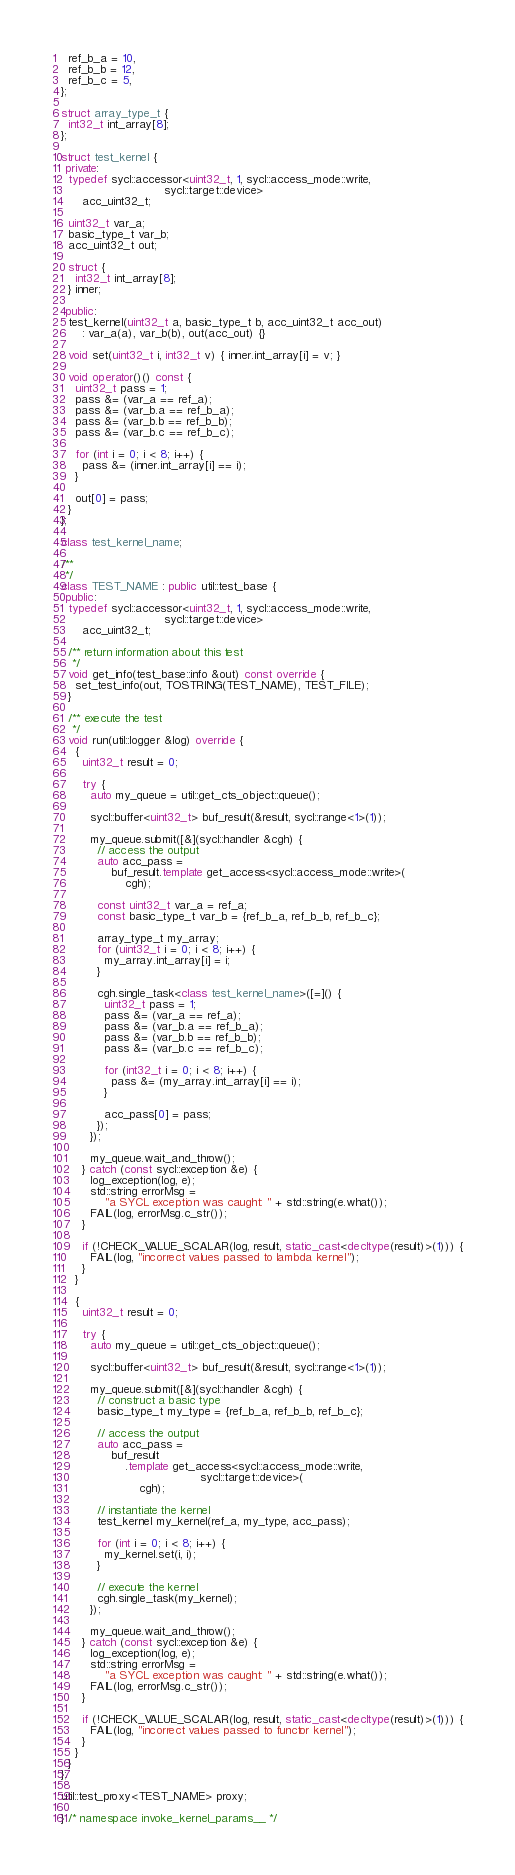Convert code to text. <code><loc_0><loc_0><loc_500><loc_500><_C++_>  ref_b_a = 10,
  ref_b_b = 12,
  ref_b_c = 5,
};

struct array_type_t {
  int32_t int_array[8];
};

struct test_kernel {
 private:
  typedef sycl::accessor<uint32_t, 1, sycl::access_mode::write,
                             sycl::target::device>
      acc_uint32_t;

  uint32_t var_a;
  basic_type_t var_b;
  acc_uint32_t out;

  struct {
    int32_t int_array[8];
  } inner;

 public:
  test_kernel(uint32_t a, basic_type_t b, acc_uint32_t acc_out)
      : var_a(a), var_b(b), out(acc_out) {}

  void set(uint32_t i, int32_t v) { inner.int_array[i] = v; }

  void operator()() const {
    uint32_t pass = 1;
    pass &= (var_a == ref_a);
    pass &= (var_b.a == ref_b_a);
    pass &= (var_b.b == ref_b_b);
    pass &= (var_b.c == ref_b_c);

    for (int i = 0; i < 8; i++) {
      pass &= (inner.int_array[i] == i);
    }

    out[0] = pass;
  }
};

class test_kernel_name;

/**
 */
class TEST_NAME : public util::test_base {
 public:
  typedef sycl::accessor<uint32_t, 1, sycl::access_mode::write,
                             sycl::target::device>
      acc_uint32_t;

  /** return information about this test
   */
  void get_info(test_base::info &out) const override {
    set_test_info(out, TOSTRING(TEST_NAME), TEST_FILE);
  }

  /** execute the test
   */
  void run(util::logger &log) override {
    {
      uint32_t result = 0;

      try {
        auto my_queue = util::get_cts_object::queue();

        sycl::buffer<uint32_t> buf_result(&result, sycl::range<1>(1));

        my_queue.submit([&](sycl::handler &cgh) {
          // access the output
          auto acc_pass =
              buf_result.template get_access<sycl::access_mode::write>(
                  cgh);

          const uint32_t var_a = ref_a;
          const basic_type_t var_b = {ref_b_a, ref_b_b, ref_b_c};

          array_type_t my_array;
          for (uint32_t i = 0; i < 8; i++) {
            my_array.int_array[i] = i;
          }

          cgh.single_task<class test_kernel_name>([=]() {
            uint32_t pass = 1;
            pass &= (var_a == ref_a);
            pass &= (var_b.a == ref_b_a);
            pass &= (var_b.b == ref_b_b);
            pass &= (var_b.c == ref_b_c);

            for (int32_t i = 0; i < 8; i++) {
              pass &= (my_array.int_array[i] == i);
            }

            acc_pass[0] = pass;
          });
        });

        my_queue.wait_and_throw();
      } catch (const sycl::exception &e) {
        log_exception(log, e);
        std::string errorMsg =
            "a SYCL exception was caught: " + std::string(e.what());
        FAIL(log, errorMsg.c_str());
      }

      if (!CHECK_VALUE_SCALAR(log, result, static_cast<decltype(result)>(1))) {
        FAIL(log, "incorrect values passed to lambda kernel");
      }
    }

    {
      uint32_t result = 0;

      try {
        auto my_queue = util::get_cts_object::queue();

        sycl::buffer<uint32_t> buf_result(&result, sycl::range<1>(1));

        my_queue.submit([&](sycl::handler &cgh) {
          // construct a basic type
          basic_type_t my_type = {ref_b_a, ref_b_b, ref_b_c};

          // access the output
          auto acc_pass =
              buf_result
                  .template get_access<sycl::access_mode::write,
                                       sycl::target::device>(
                      cgh);

          // instantiate the kernel
          test_kernel my_kernel(ref_a, my_type, acc_pass);

          for (int i = 0; i < 8; i++) {
            my_kernel.set(i, i);
          }

          // execute the kernel
          cgh.single_task(my_kernel);
        });

        my_queue.wait_and_throw();
      } catch (const sycl::exception &e) {
        log_exception(log, e);
        std::string errorMsg =
            "a SYCL exception was caught: " + std::string(e.what());
        FAIL(log, errorMsg.c_str());
      }

      if (!CHECK_VALUE_SCALAR(log, result, static_cast<decltype(result)>(1))) {
        FAIL(log, "incorrect values passed to functor kernel");
      }
    }
  }
};

util::test_proxy<TEST_NAME> proxy;

} /* namespace invoke_kernel_params__ */
</code> 